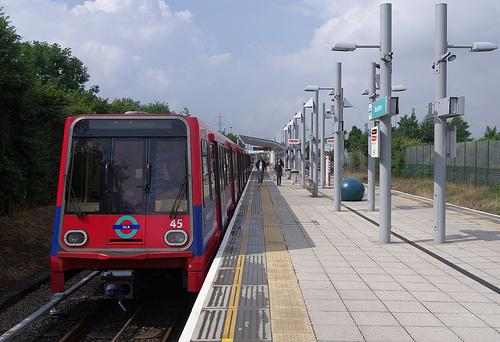Identify two objects present on the overhead passenger shelter. A green and white street sign and a sign hanging on a pole. What is the approximate width and height of the area that has people walking on the platform? The width is around 50, and the height is approximately 50 as well. Describe some of the weather and lighting conditions shown in the image. It is a sunny day with fluffy clouds in the sky, and the photo was taken during the day when the light is bright. How many headlights are there on the train, and what is another feature on the train's front? There are two headlights on the train, and another feature is the number 45 written on the front of the train. What are the people in the image doing, and where are they? Passengers are walking down the platform, likely boarding or exiting a red and blue train at the train station. List three details about the train platform area. The platform is made of concrete, it has a fence along it, and there are light posts lining the platform. Mention one object that may be related to safety measures for passengers on the platform. Yellow lines on the platform to indicate safe distances from the train tracks. What type of mood or atmosphere does the image portray and why? The image portrays a lively and bustling atmosphere as passengers walk on the platform while a red and blue train serves as the central subject. Explain the significance of the number 45 on the train. The number 45 might be an identifier for the train, such as its route or line number. What color is the train in the image and where is it located? The train is red and blue, and it is on the tracks at a platform for passengers. Is there a green ball in the image? No, there is a large teal decorative ball and a black decorative stone ball. What are the tracks in the image made of? Metal What type of weather does the image depict? Sunny daytime Is there any graffiti on the train? No, there is no graffiti on the train. What are the different lines observed on the platform? Yellow and white lines In the image, can you identify the emotion of any person? No, the faces of the people cannot be seen. Can the conductor be seen in the image? No, the conductor cannot be seen. What color is the train in the image? Red Choose the correct description of the platform: a) covered in snow b) surrounded by water c) sunny and busy  sunny and busy Is there any signage on the platform's light posts? Yes, there is a sign hanging on a light post. What is the color of the light posts lining the platform? Grey What are the people in the image doing? They are walking on the platform. What is the train's platform made of? Concrete Describe the fence in the image. The fence is along the platform area and can be seen on the right. What is the color of the decorative ball in the image? Teal Can you identify any trees in the image? Yes, there is a tree with green leaves. Describe the photo taken during the day. The image shows a red and blue train on train tracks near a concrete passenger platform with people walking on it, light posts, a fence, a terminal point, and fluffy clouds in the sky. Describe the train seen in the image. The train is red and blue with the number 45 written on the front and has a glass windshield, windshield wipers, and a headlight. Find any text written on the train in the image. 45 If a person were to plan an event in the image, what would be a suitable description? A sunny day for train riding at a passenger boarding platform with a red and blue train numbered 45. 